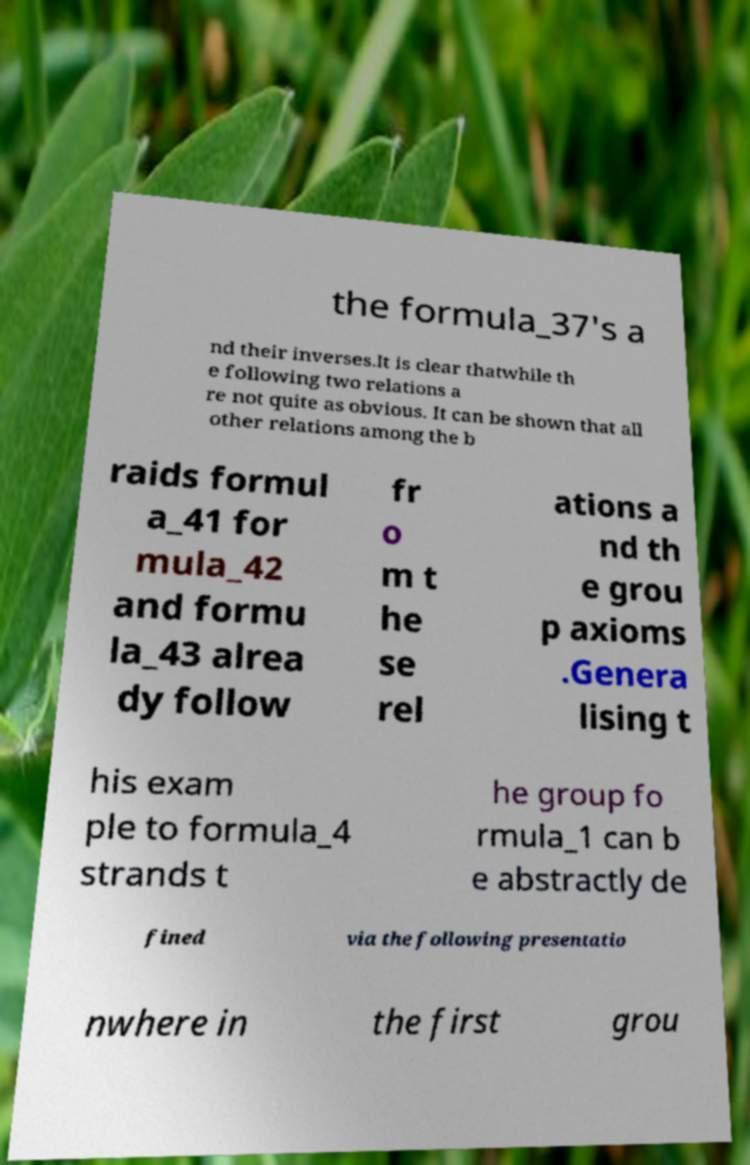Please identify and transcribe the text found in this image. the formula_37's a nd their inverses.It is clear thatwhile th e following two relations a re not quite as obvious. It can be shown that all other relations among the b raids formul a_41 for mula_42 and formu la_43 alrea dy follow fr o m t he se rel ations a nd th e grou p axioms .Genera lising t his exam ple to formula_4 strands t he group fo rmula_1 can b e abstractly de fined via the following presentatio nwhere in the first grou 